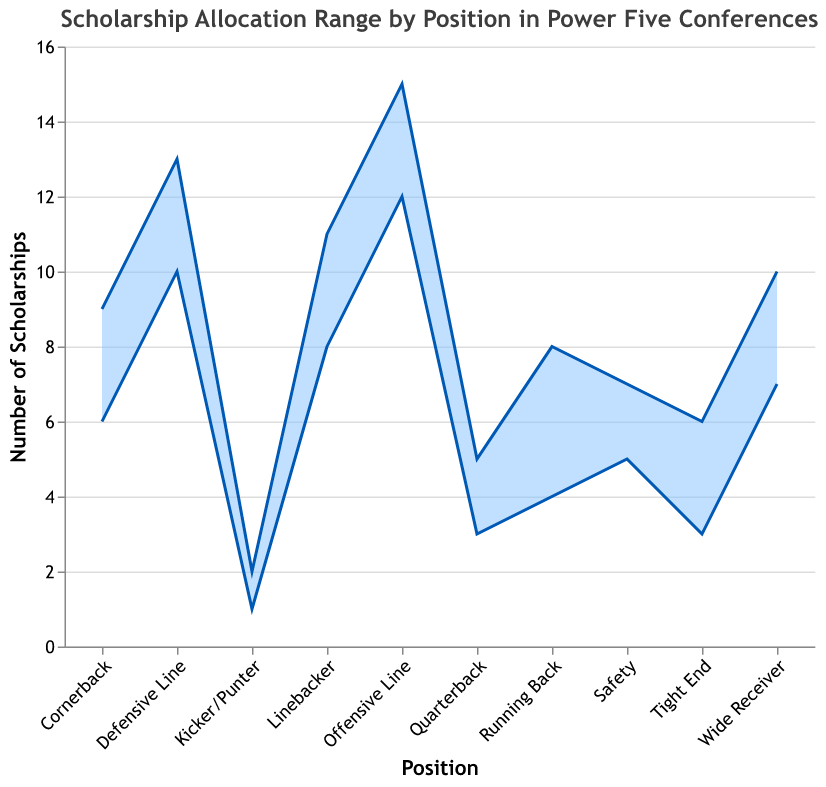What is the title of the figure? The title is clearly specified at the top of the chart.
Answer: Scholarship Allocation Range by Position in Power Five Conferences Which position has the highest maximum number of scholarships? By examining the maximum values on the chart, you can see that the Offensive Line has the highest maximum number of scholarships at 15.
Answer: Offensive Line How many scholarships are allocated to punters/kickers at most? The maximum number for punters/kickers can be seen directly in the chart, which is 2.
Answer: 2 From which position to which position do the ranges for Running Back span? Look at the starting and ending points of the Running Back area in the range chart to see that it spans from 4 to 8.
Answer: 4 to 8 What is the average range of scholarships for the Quarterback position? The average can be calculated by summing the minimum and maximum values (3 + 5 = 8) and then dividing by 2 (8/2 = 4).
Answer: 4 Which two positions have the same minimum number of 3 scholarships? By observing the chart, you can see that both the Quarterback and Tight End positions have a minimum of 3 scholarships.
Answer: Quarterback and Tight End Is there any position with the same minimum and maximum scholarship allocation? Look for positions where the shaded area is a single line, indicating equal min and max values; for Kicker/Punter, both are 1 and 2, which does not count as equal. Hence, no position has the same min and max allocations.
Answer: No How does the range for Wide Receiver compare to the range for Tight End? The range for Wide Receiver (7-10) is wider than that for Tight End (3-6). You can see this by comparing the extent of the shaded areas for both positions.
Answer: Wider What is the difference in the maximum number of scholarships between Defensive Line and Linebacker? Subtract the maximum number of scholarships for Linebacker (11) from that for Defensive Line (13) to find the difference (13 - 11 = 2).
Answer: 2 Which positions have a minimum of fewer than 5 scholarships? From the chart, the positions with fewer than 5 scholarships minimum are Quarterback, Tight End, and Kicker/Punter.
Answer: Quarterback, Tight End, Kicker/Punter 